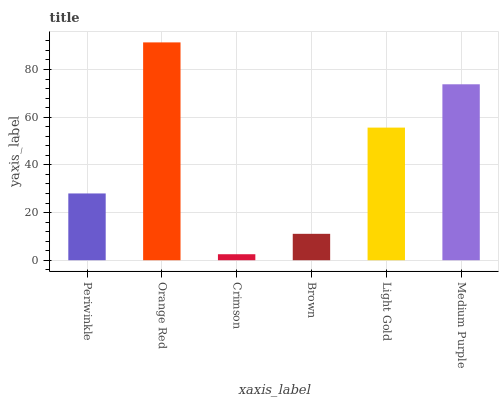Is Crimson the minimum?
Answer yes or no. Yes. Is Orange Red the maximum?
Answer yes or no. Yes. Is Orange Red the minimum?
Answer yes or no. No. Is Crimson the maximum?
Answer yes or no. No. Is Orange Red greater than Crimson?
Answer yes or no. Yes. Is Crimson less than Orange Red?
Answer yes or no. Yes. Is Crimson greater than Orange Red?
Answer yes or no. No. Is Orange Red less than Crimson?
Answer yes or no. No. Is Light Gold the high median?
Answer yes or no. Yes. Is Periwinkle the low median?
Answer yes or no. Yes. Is Orange Red the high median?
Answer yes or no. No. Is Brown the low median?
Answer yes or no. No. 